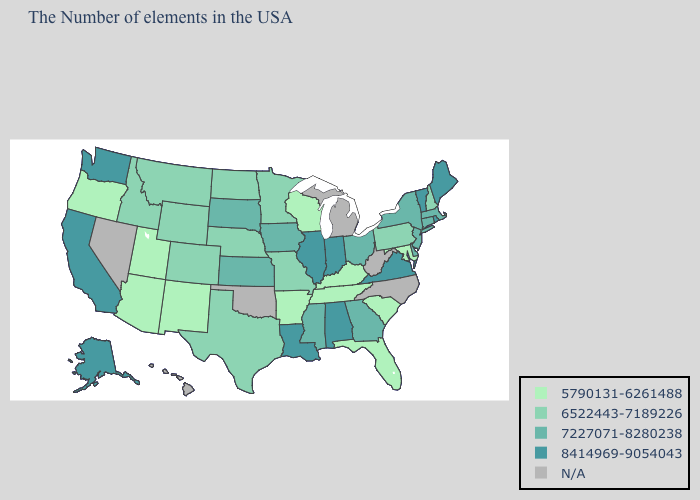Does the map have missing data?
Write a very short answer. Yes. What is the lowest value in states that border Maryland?
Concise answer only. 6522443-7189226. What is the value of South Carolina?
Be succinct. 5790131-6261488. Does Pennsylvania have the lowest value in the Northeast?
Quick response, please. Yes. Name the states that have a value in the range 8414969-9054043?
Give a very brief answer. Maine, Rhode Island, Vermont, Virginia, Indiana, Alabama, Illinois, Louisiana, California, Washington, Alaska. Does Alaska have the lowest value in the USA?
Short answer required. No. Name the states that have a value in the range 8414969-9054043?
Quick response, please. Maine, Rhode Island, Vermont, Virginia, Indiana, Alabama, Illinois, Louisiana, California, Washington, Alaska. What is the value of Minnesota?
Be succinct. 6522443-7189226. What is the value of Kentucky?
Be succinct. 5790131-6261488. Name the states that have a value in the range N/A?
Give a very brief answer. North Carolina, West Virginia, Michigan, Oklahoma, Nevada, Hawaii. What is the lowest value in states that border Indiana?
Short answer required. 5790131-6261488. Name the states that have a value in the range 7227071-8280238?
Quick response, please. Massachusetts, Connecticut, New York, New Jersey, Delaware, Ohio, Georgia, Mississippi, Iowa, Kansas, South Dakota. What is the value of Ohio?
Be succinct. 7227071-8280238. Name the states that have a value in the range 7227071-8280238?
Keep it brief. Massachusetts, Connecticut, New York, New Jersey, Delaware, Ohio, Georgia, Mississippi, Iowa, Kansas, South Dakota. 